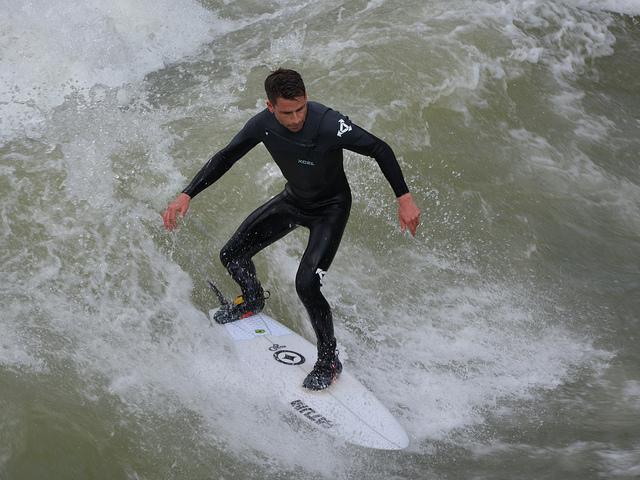How many zebras have stripes?
Give a very brief answer. 0. 